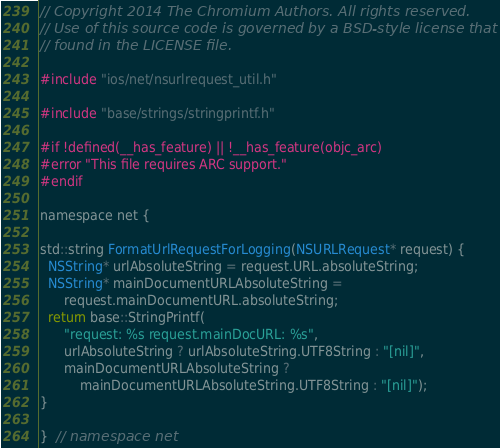<code> <loc_0><loc_0><loc_500><loc_500><_ObjectiveC_>// Copyright 2014 The Chromium Authors. All rights reserved.
// Use of this source code is governed by a BSD-style license that can be
// found in the LICENSE file.

#include "ios/net/nsurlrequest_util.h"

#include "base/strings/stringprintf.h"

#if !defined(__has_feature) || !__has_feature(objc_arc)
#error "This file requires ARC support."
#endif

namespace net {

std::string FormatUrlRequestForLogging(NSURLRequest* request) {
  NSString* urlAbsoluteString = request.URL.absoluteString;
  NSString* mainDocumentURLAbsoluteString =
      request.mainDocumentURL.absoluteString;
  return base::StringPrintf(
      "request: %s request.mainDocURL: %s",
      urlAbsoluteString ? urlAbsoluteString.UTF8String : "[nil]",
      mainDocumentURLAbsoluteString ?
          mainDocumentURLAbsoluteString.UTF8String : "[nil]");
}

}  // namespace net
</code> 